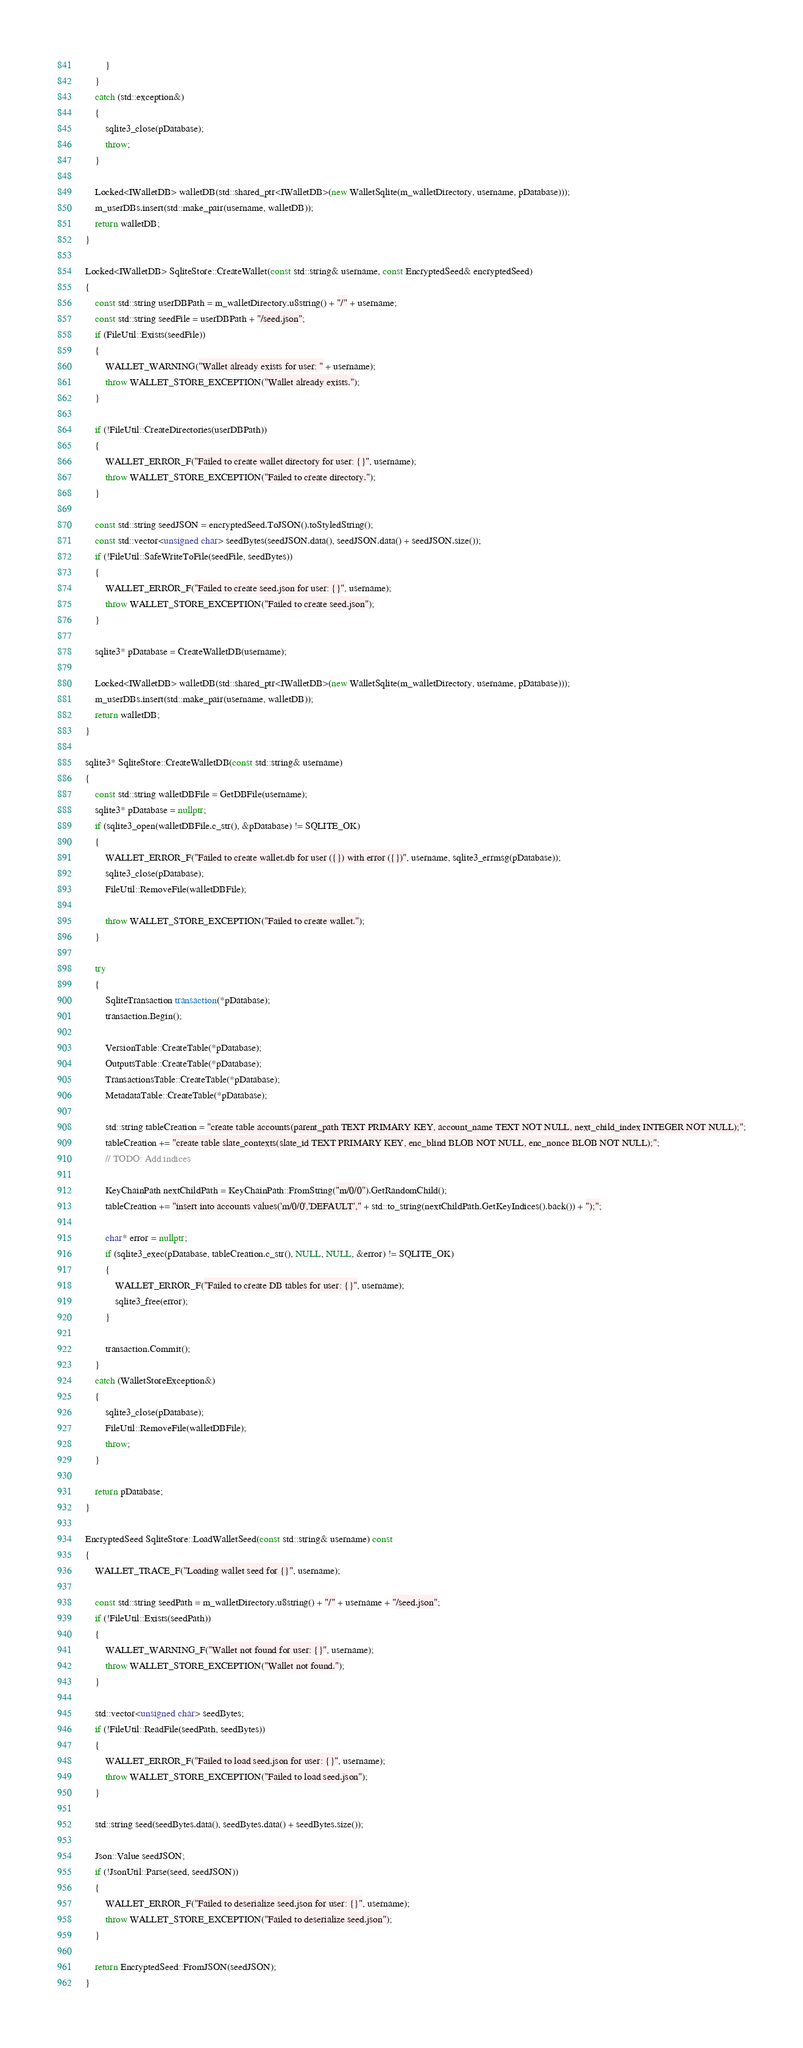<code> <loc_0><loc_0><loc_500><loc_500><_C++_>		}
	}
	catch (std::exception&)
	{
		sqlite3_close(pDatabase);
		throw;
	}

	Locked<IWalletDB> walletDB(std::shared_ptr<IWalletDB>(new WalletSqlite(m_walletDirectory, username, pDatabase)));
	m_userDBs.insert(std::make_pair(username, walletDB));
	return walletDB;
}

Locked<IWalletDB> SqliteStore::CreateWallet(const std::string& username, const EncryptedSeed& encryptedSeed)
{
	const std::string userDBPath = m_walletDirectory.u8string() + "/" + username;
	const std::string seedFile = userDBPath + "/seed.json";
	if (FileUtil::Exists(seedFile))
	{
		WALLET_WARNING("Wallet already exists for user: " + username);
		throw WALLET_STORE_EXCEPTION("Wallet already exists.");
	}

	if (!FileUtil::CreateDirectories(userDBPath))
	{
		WALLET_ERROR_F("Failed to create wallet directory for user: {}", username);
		throw WALLET_STORE_EXCEPTION("Failed to create directory.");
	}

	const std::string seedJSON = encryptedSeed.ToJSON().toStyledString();
	const std::vector<unsigned char> seedBytes(seedJSON.data(), seedJSON.data() + seedJSON.size());
	if (!FileUtil::SafeWriteToFile(seedFile, seedBytes))
	{
		WALLET_ERROR_F("Failed to create seed.json for user: {}", username);
		throw WALLET_STORE_EXCEPTION("Failed to create seed.json");
	}

	sqlite3* pDatabase = CreateWalletDB(username);

	Locked<IWalletDB> walletDB(std::shared_ptr<IWalletDB>(new WalletSqlite(m_walletDirectory, username, pDatabase)));
	m_userDBs.insert(std::make_pair(username, walletDB));
	return walletDB;
}

sqlite3* SqliteStore::CreateWalletDB(const std::string& username)
{
	const std::string walletDBFile = GetDBFile(username);
	sqlite3* pDatabase = nullptr;
	if (sqlite3_open(walletDBFile.c_str(), &pDatabase) != SQLITE_OK)
	{
		WALLET_ERROR_F("Failed to create wallet.db for user ({}) with error ({})", username, sqlite3_errmsg(pDatabase));
		sqlite3_close(pDatabase);
		FileUtil::RemoveFile(walletDBFile);

		throw WALLET_STORE_EXCEPTION("Failed to create wallet.");
	}

	try
	{
		SqliteTransaction transaction(*pDatabase);
		transaction.Begin();

		VersionTable::CreateTable(*pDatabase);
		OutputsTable::CreateTable(*pDatabase);
		TransactionsTable::CreateTable(*pDatabase);
		MetadataTable::CreateTable(*pDatabase);

		std::string tableCreation = "create table accounts(parent_path TEXT PRIMARY KEY, account_name TEXT NOT NULL, next_child_index INTEGER NOT NULL);";
		tableCreation += "create table slate_contexts(slate_id TEXT PRIMARY KEY, enc_blind BLOB NOT NULL, enc_nonce BLOB NOT NULL);";
		// TODO: Add indices

		KeyChainPath nextChildPath = KeyChainPath::FromString("m/0/0").GetRandomChild();
		tableCreation += "insert into accounts values('m/0/0','DEFAULT'," + std::to_string(nextChildPath.GetKeyIndices().back()) + ");";

		char* error = nullptr;
		if (sqlite3_exec(pDatabase, tableCreation.c_str(), NULL, NULL, &error) != SQLITE_OK)
		{
			WALLET_ERROR_F("Failed to create DB tables for user: {}", username);
			sqlite3_free(error);
		}

		transaction.Commit();
	}
	catch (WalletStoreException&)
	{
		sqlite3_close(pDatabase);
		FileUtil::RemoveFile(walletDBFile);
		throw;
	}

	return pDatabase;
}

EncryptedSeed SqliteStore::LoadWalletSeed(const std::string& username) const
{
	WALLET_TRACE_F("Loading wallet seed for {}", username);

	const std::string seedPath = m_walletDirectory.u8string() + "/" + username + "/seed.json";
	if (!FileUtil::Exists(seedPath))
	{
		WALLET_WARNING_F("Wallet not found for user: {}", username);
		throw WALLET_STORE_EXCEPTION("Wallet not found.");
	}

	std::vector<unsigned char> seedBytes;
	if (!FileUtil::ReadFile(seedPath, seedBytes))
	{
		WALLET_ERROR_F("Failed to load seed.json for user: {}", username);
		throw WALLET_STORE_EXCEPTION("Failed to load seed.json");
	}

	std::string seed(seedBytes.data(), seedBytes.data() + seedBytes.size());

	Json::Value seedJSON;
	if (!JsonUtil::Parse(seed, seedJSON))
	{
		WALLET_ERROR_F("Failed to deserialize seed.json for user: {}", username);
		throw WALLET_STORE_EXCEPTION("Failed to deserialize seed.json");
	}

	return EncryptedSeed::FromJSON(seedJSON);
}</code> 